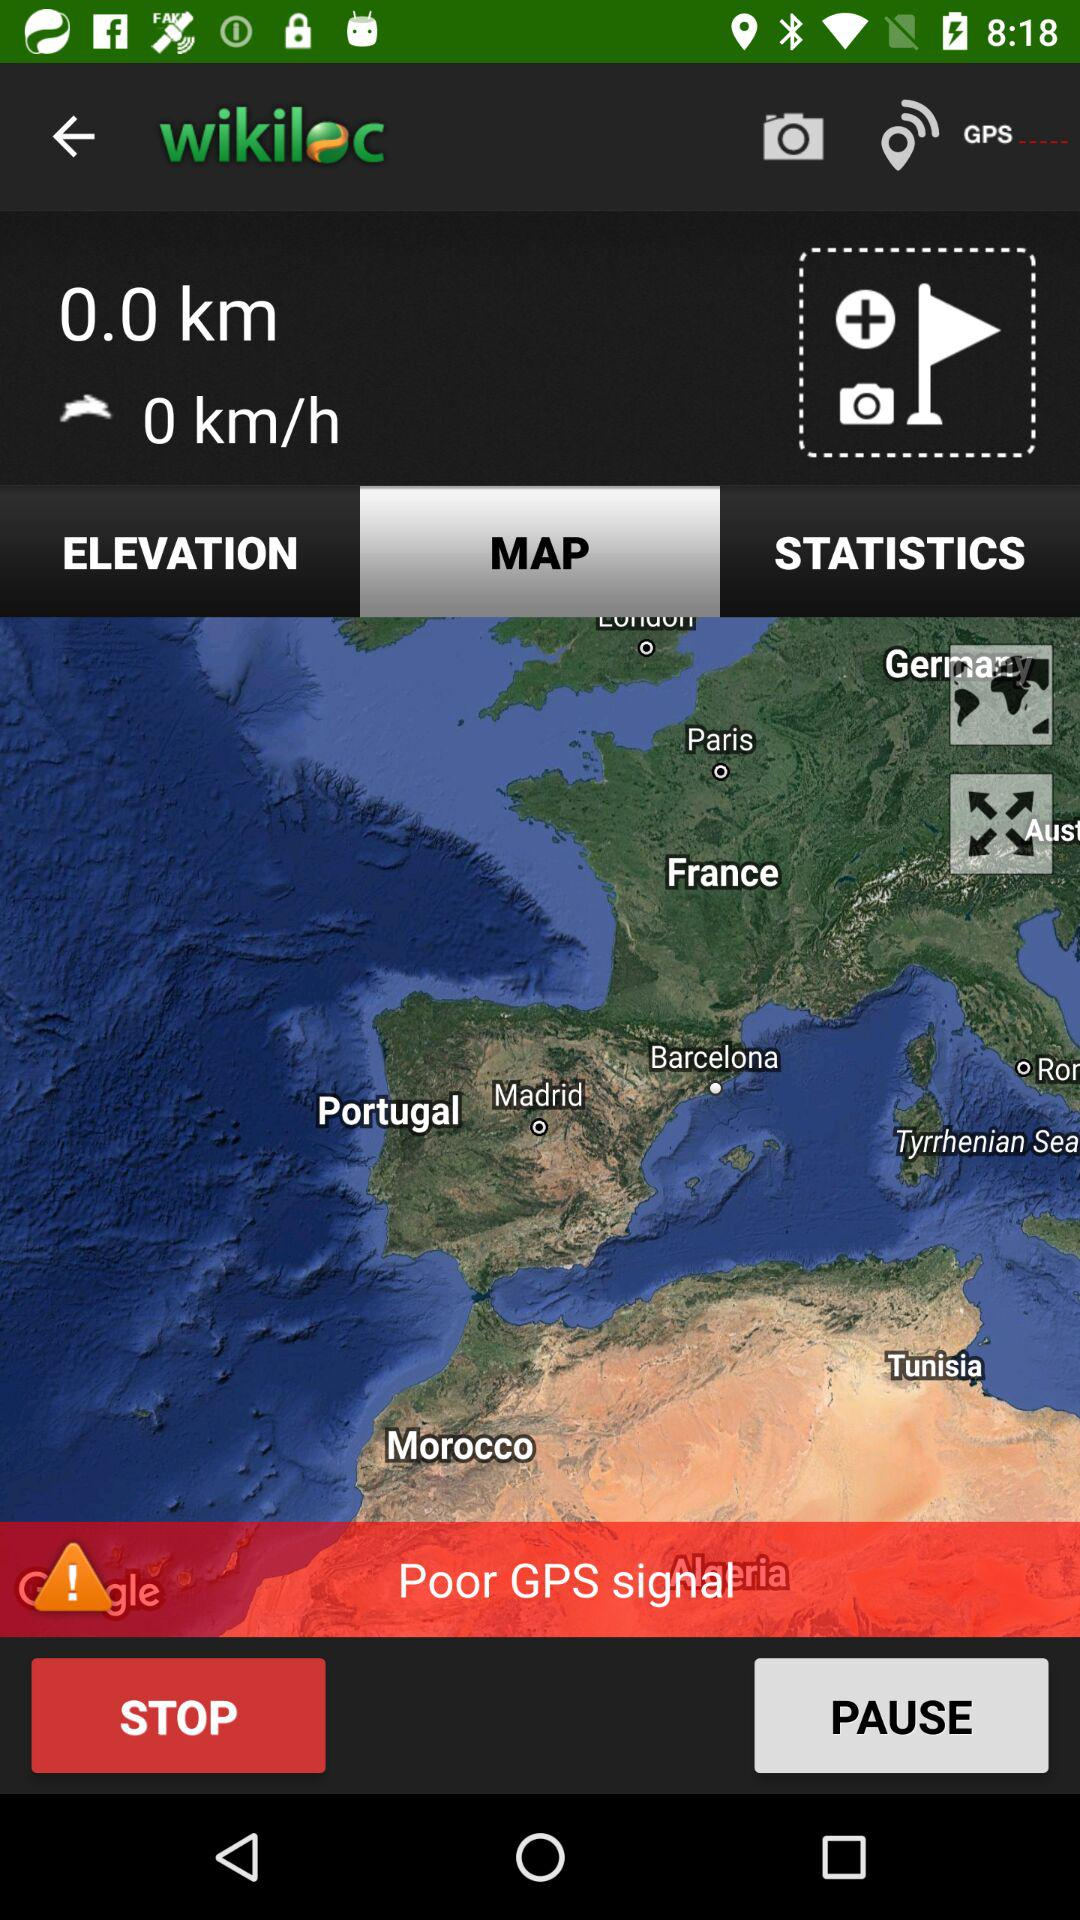What is the name of the application? The application name is "wikiloc". 